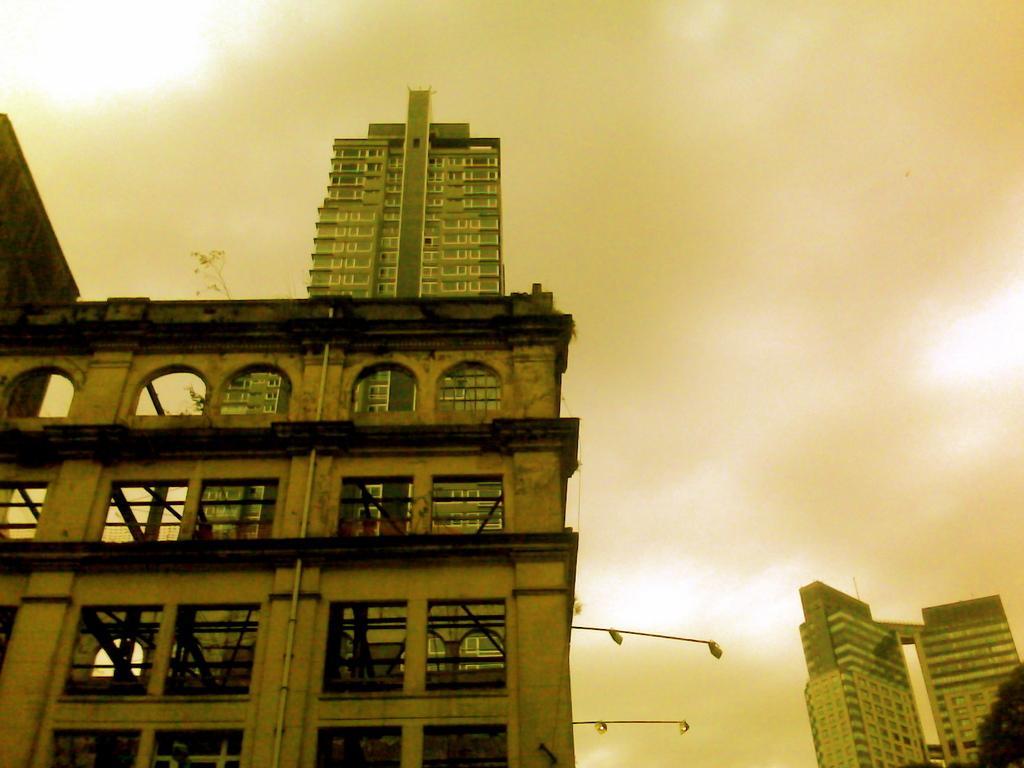Please provide a concise description of this image. In this picture we can see a brown color building with many arch design windows seen in the image. Behind we can see big building. 